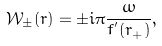Convert formula to latex. <formula><loc_0><loc_0><loc_500><loc_500>\mathcal { W } _ { \pm } ( r ) = \pm i \pi \frac { \omega } { f ^ { ^ { \prime } } ( r _ { + } ) } ,</formula> 